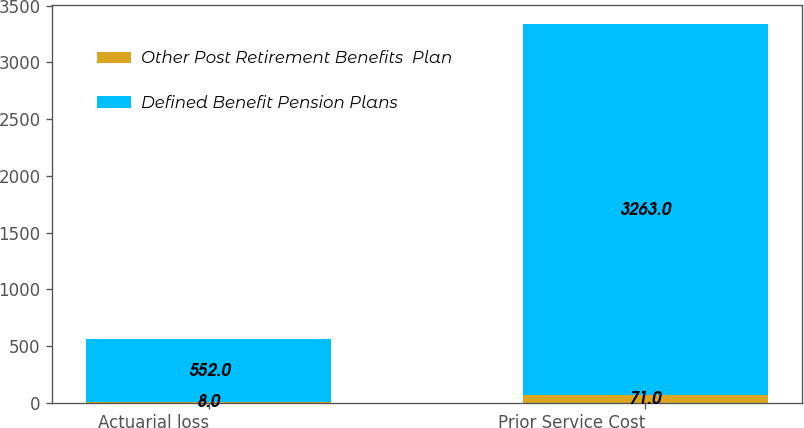Convert chart to OTSL. <chart><loc_0><loc_0><loc_500><loc_500><stacked_bar_chart><ecel><fcel>Actuarial loss<fcel>Prior Service Cost<nl><fcel>Other Post Retirement Benefits  Plan<fcel>8<fcel>71<nl><fcel>Defined Benefit Pension Plans<fcel>552<fcel>3263<nl></chart> 